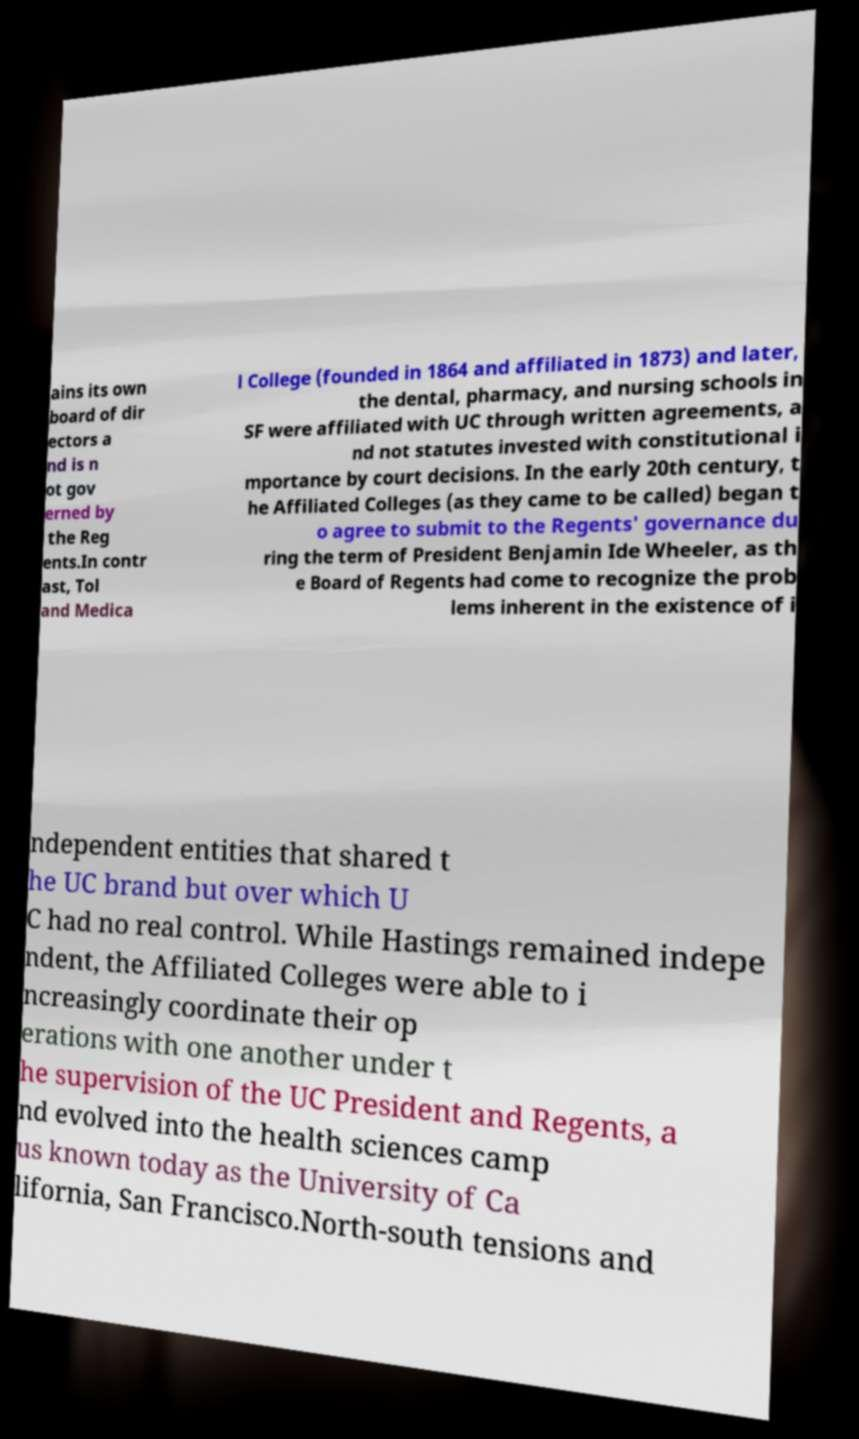For documentation purposes, I need the text within this image transcribed. Could you provide that? ains its own board of dir ectors a nd is n ot gov erned by the Reg ents.In contr ast, Tol and Medica l College (founded in 1864 and affiliated in 1873) and later, the dental, pharmacy, and nursing schools in SF were affiliated with UC through written agreements, a nd not statutes invested with constitutional i mportance by court decisions. In the early 20th century, t he Affiliated Colleges (as they came to be called) began t o agree to submit to the Regents' governance du ring the term of President Benjamin Ide Wheeler, as th e Board of Regents had come to recognize the prob lems inherent in the existence of i ndependent entities that shared t he UC brand but over which U C had no real control. While Hastings remained indepe ndent, the Affiliated Colleges were able to i ncreasingly coordinate their op erations with one another under t he supervision of the UC President and Regents, a nd evolved into the health sciences camp us known today as the University of Ca lifornia, San Francisco.North-south tensions and 